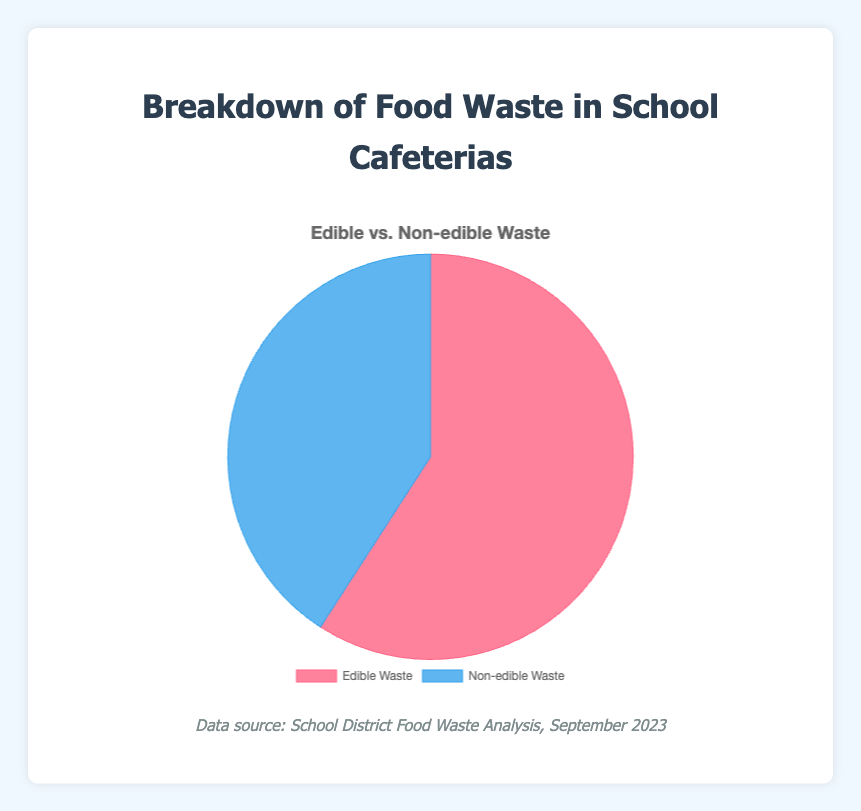Which type of waste constitutes the larger portion in the pie chart? By looking at the sizes of the slices in the pie chart, it's noticeable that one slice is larger than the other. Since edible and non-edible are the two types, edible waste has a larger portion.
Answer: Edible waste What is the combined total weight of edible and non-edible waste? According to the pie chart, the total food waste is the sum of the edible and non-edible waste: 680 kg of edible waste and 470 kg of non-edible waste. Adding these together, 680 + 470 = 1150 kg.
Answer: 1150 kg What percentage of the total food waste is non-edible? From the pie chart, we know the total weights: 680 kg edible and 470 kg non-edible. The percentage is calculated as (non-edible / total) * 100. Thus, (470 / 1150) * 100 ≈ 40.87%.
Answer: 40.87% How does the edible waste compare to the non-edible waste in terms of weight? The chart shows the weights: 680 kg edible and 470 kg non-edible. Edible waste is greater than non-edible waste by 680 - 470 = 210 kg.
Answer: Edible waste is 210 kg greater What color represents the edible waste in the pie chart? The pie chart uses different colors to represent the types of waste. The edible waste slice is colored in red.
Answer: Red If the total food waste is reduced by 10%, what would the new total waste be? The current total food waste is 1150 kg. Reducing it by 10% equates to 1150 * 0.10 = 115 kg. Thus, the new total waste would be 1150 - 115 = 1035 kg.
Answer: 1035 kg What is the ratio of edible waste to non-edible waste? The chart shows the weights: 680 kg edible and 470 kg non-edible. The ratio of edible to non-edible waste is 680:470, which simplifies to approximately 1.45:1.
Answer: 1.45:1 